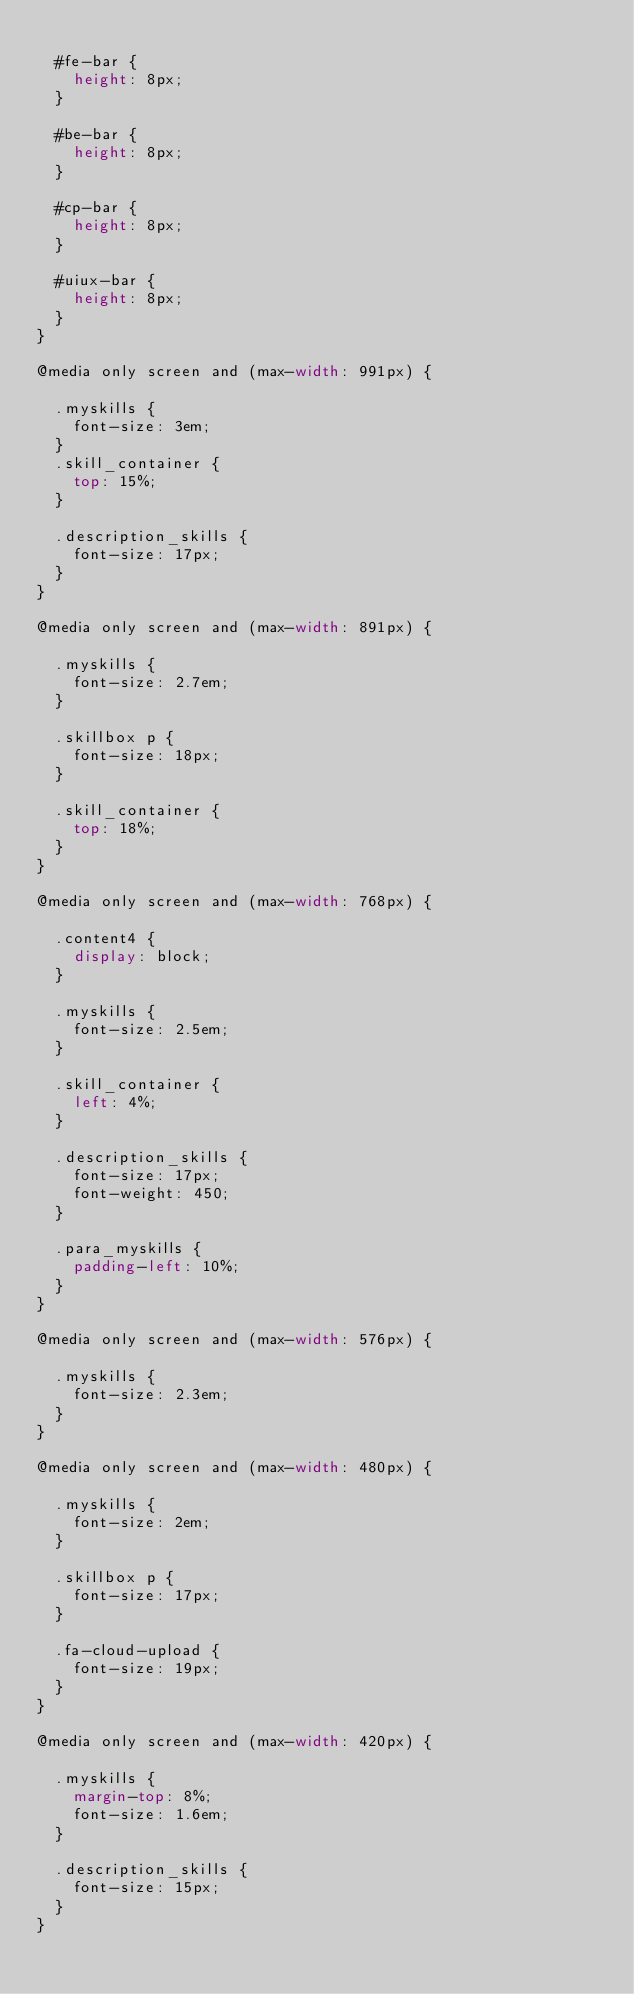Convert code to text. <code><loc_0><loc_0><loc_500><loc_500><_CSS_>
  #fe-bar {
    height: 8px;
  }

  #be-bar {
    height: 8px;
  }

  #cp-bar {
    height: 8px;
  }

  #uiux-bar {
    height: 8px;
  }
}

@media only screen and (max-width: 991px) {

  .myskills {
    font-size: 3em;
  }
  .skill_container {
    top: 15%;
  }

  .description_skills {
    font-size: 17px;
  }
}

@media only screen and (max-width: 891px) {

  .myskills {
    font-size: 2.7em;
  }

  .skillbox p {
    font-size: 18px;
  }

  .skill_container {
    top: 18%;
  }
}

@media only screen and (max-width: 768px) {

  .content4 {
    display: block;
  }

  .myskills {
    font-size: 2.5em;
  }
  
  .skill_container {
    left: 4%;
  }

  .description_skills {
    font-size: 17px;
    font-weight: 450;
  }

  .para_myskills {
    padding-left: 10%;
  }
}

@media only screen and (max-width: 576px) {

  .myskills {
    font-size: 2.3em;
  }
}

@media only screen and (max-width: 480px) {

  .myskills {
    font-size: 2em;
  }

  .skillbox p {
    font-size: 17px;
  }

  .fa-cloud-upload {
    font-size: 19px;
  }
}

@media only screen and (max-width: 420px) {

  .myskills {
    margin-top: 8%;
    font-size: 1.6em;
  }

  .description_skills {
    font-size: 15px;
  }
}</code> 